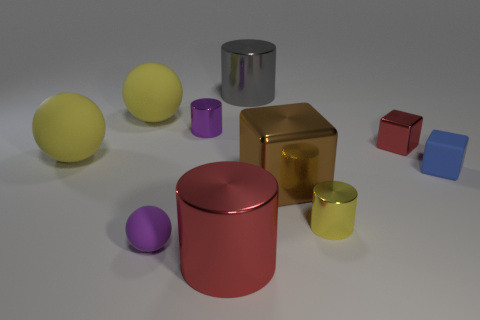The yellow shiny object that is the same size as the red metal cube is what shape?
Your response must be concise. Cylinder. Are there fewer small yellow shiny cylinders than big rubber things?
Your answer should be compact. Yes. What number of cylinders have the same size as the blue thing?
Your response must be concise. 2. What is the shape of the metal object that is the same color as the tiny shiny block?
Ensure brevity in your answer.  Cylinder. What is the material of the small purple cylinder?
Make the answer very short. Metal. There is a cylinder on the right side of the large brown block; what size is it?
Your response must be concise. Small. What number of small blue matte objects are the same shape as the small red metal object?
Ensure brevity in your answer.  1. There is a large red object that is the same material as the tiny yellow object; what shape is it?
Provide a succinct answer. Cylinder. How many cyan things are cylinders or big metal cylinders?
Provide a succinct answer. 0. Are there any metal cylinders behind the small ball?
Your answer should be very brief. Yes. 